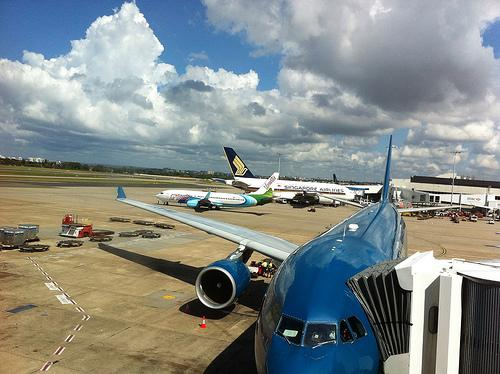Describe the image in a poetic manner with attention to details. Amidst the blue expanse, the vast canvas of fluffy white clouds witnesses two magnificent, metallic birds, grounded and preparing to embark on yet another journey, as an unassuming orange cone stands sentinel, guarding the sacred space. Utilize a single sentence to describe the main elements in the image. The image features two airplanes sitting on the tarmac at an airport, with a walkway, large white clouds in the sky, an orange cone on the ground, and writing on the side of one of the planes. Identify prominent features in the photograph and describe them briefly. The image exhibits several prominent features, including two airplanes on the tarmac, a plethora of white clouds scattered across a blue sky, an orange and white cone on the ground, and various shadows. State what can be observed in the photograph using simple language. In the picture, you can see two airplanes, a few clouds in the sky, some shadows on the ground, an orange cone, and writing on one of the planes. Give a brief overview of the scene captured in the image. The image captures a daytime scene at an airport, with two planes on the tarmac, white clouds in the sky, and an orange cone on the ground. Mention the key elements in the picture and their respective positioning. A pair of airplanes on the tarmac, huge white clouds in the blue sky, an orange-and-white cone on the ground, and shadows from the wings can be seen in the image. Provide a concise description of the main features in the photograph. The image shows two airplanes at the airport, one owned by Singapore Airlines, with an orange cone on the ground, large white clouds in the sky, and shadows cast by the planes. Briefly explain what you see in the image and the environment it depicts. The image displays a daytime airport scene with two airplanes on the tarmac, fluffy white clouds in the sky, and distinctive elements such as an orange cone on the ground and writing on one of the planes. Recount the significant components of the picture, paying attention to various elements. The image contains a diverse range of elements, including two airplanes situated at the airport, a vast expanse of white clouds, an orange cone nestled among the shadows cast by the planes, and distinct lettering on one of the aircrafts. Provide a description of the image focusing on the aircrafts and their surroundings. Two majestic airplanes rest on the tarmac, bathed in daylight, under the watchful gaze of the enormous white clouds above and surrounded by orange cones and a variety of shadows cast upon the ground. 